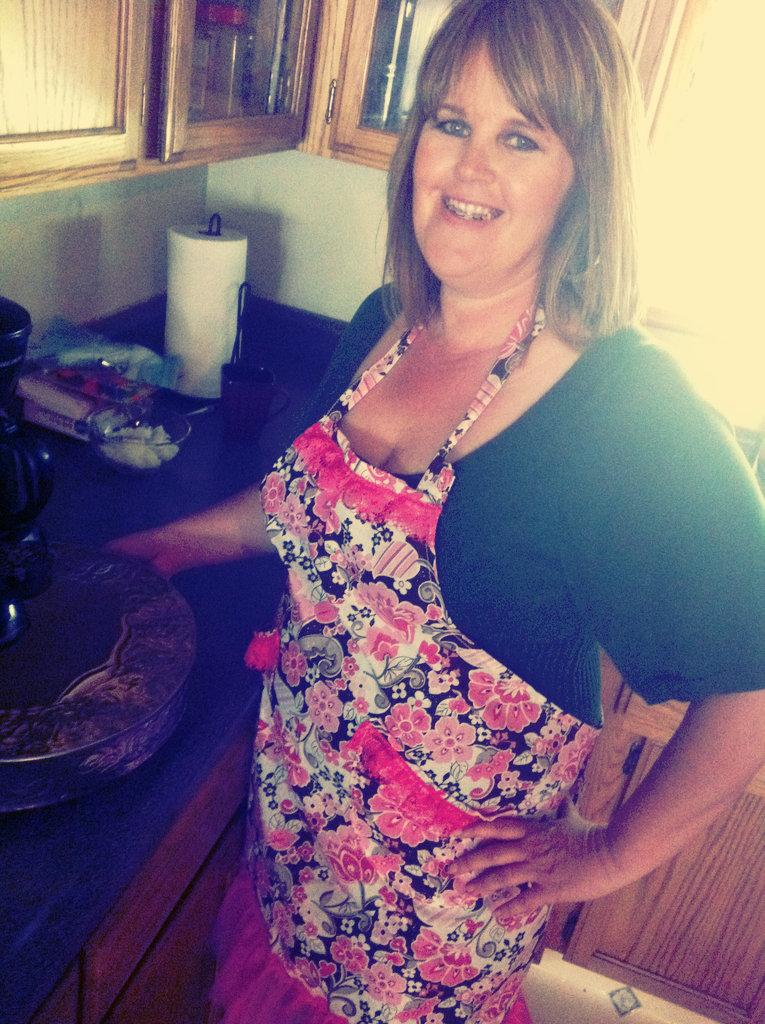What is the woman doing in the image? The woman is standing and smiling in the image. What can be seen on the table in the image? There is a cup and a tissue roller on the table. Are there any other objects on the table? Yes, there are other objects on the table. What is visible at the top and bottom of the image? There are cupboards at the top and bottom of the image. What type of steam is coming out of the woman's stomach in the image? There is no steam coming out of the woman's stomach in the image; she is simply standing and smiling. 